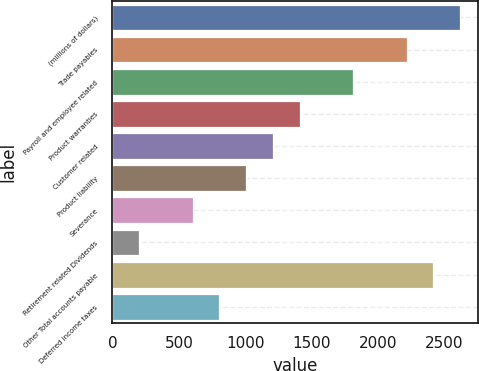<chart> <loc_0><loc_0><loc_500><loc_500><bar_chart><fcel>(millions of dollars)<fcel>Trade payables<fcel>Payroll and employee related<fcel>Product warranties<fcel>Customer related<fcel>Product liability<fcel>Severance<fcel>Retirement related Dividends<fcel>Other Total accounts payable<fcel>Deferred income taxes<nl><fcel>2618.05<fcel>2215.35<fcel>1812.65<fcel>1409.95<fcel>1208.6<fcel>1007.25<fcel>604.55<fcel>201.85<fcel>2416.7<fcel>805.9<nl></chart> 